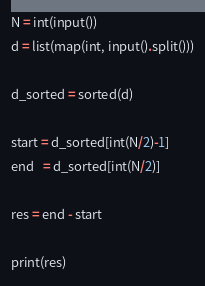<code> <loc_0><loc_0><loc_500><loc_500><_Python_>N = int(input())
d = list(map(int, input().split()))

d_sorted = sorted(d)

start = d_sorted[int(N/2)-1]
end   = d_sorted[int(N/2)]

res = end - start

print(res)</code> 